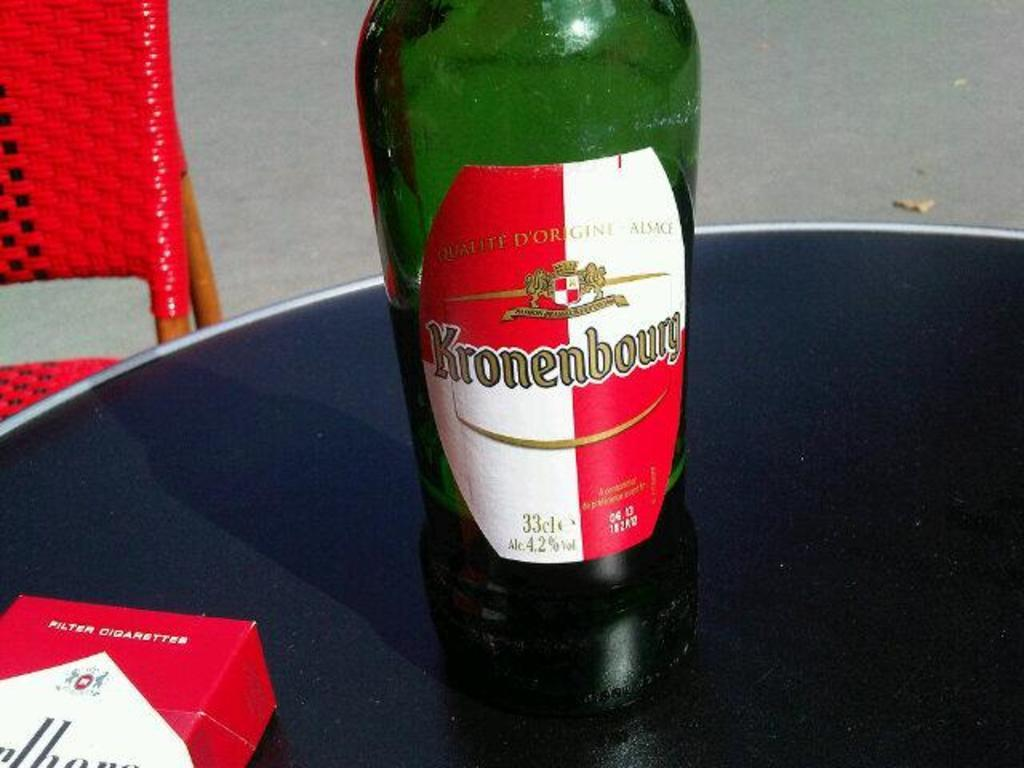<image>
Share a concise interpretation of the image provided. A half full green bottle with a red and white label of Kronenbourg. 